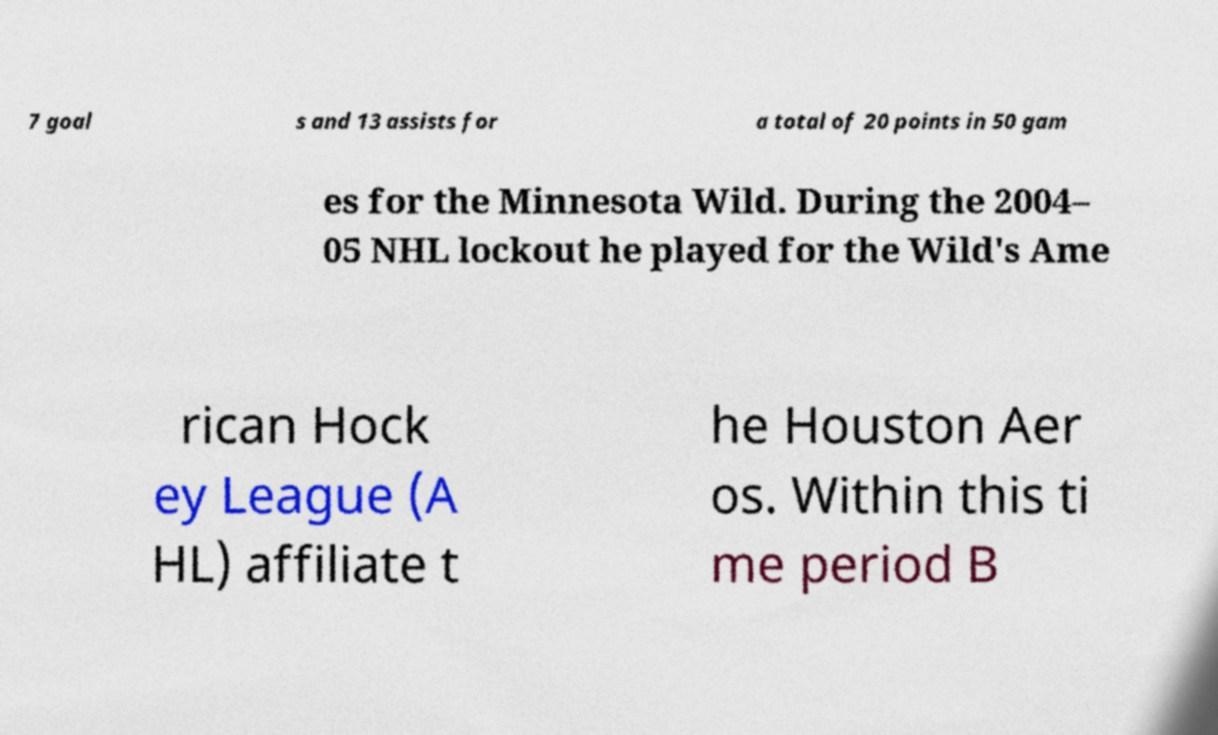For documentation purposes, I need the text within this image transcribed. Could you provide that? 7 goal s and 13 assists for a total of 20 points in 50 gam es for the Minnesota Wild. During the 2004– 05 NHL lockout he played for the Wild's Ame rican Hock ey League (A HL) affiliate t he Houston Aer os. Within this ti me period B 